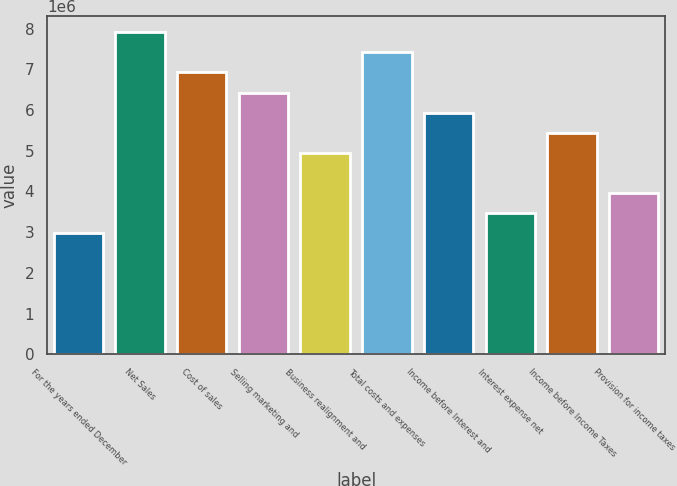Convert chart to OTSL. <chart><loc_0><loc_0><loc_500><loc_500><bar_chart><fcel>For the years ended December<fcel>Net Sales<fcel>Cost of sales<fcel>Selling marketing and<fcel>Business realignment and<fcel>Total costs and expenses<fcel>Income before Interest and<fcel>Interest expense net<fcel>Income before Income Taxes<fcel>Provision for income taxes<nl><fcel>2.96803e+06<fcel>7.91475e+06<fcel>6.9254e+06<fcel>6.43073e+06<fcel>4.94672e+06<fcel>7.42007e+06<fcel>5.93606e+06<fcel>3.4627e+06<fcel>5.44139e+06<fcel>3.95737e+06<nl></chart> 